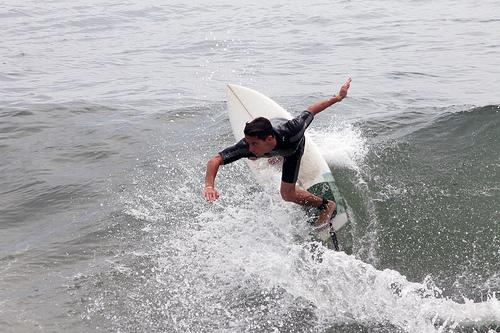Question: what is the man doing?
Choices:
A. Swimming.
B. Skiing.
C. Surfing.
D. Ice skating.
Answer with the letter. Answer: C Question: what motion is the water?
Choices:
A. Still.
B. Smooth.
C. Wavy.
D. Rocky.
Answer with the letter. Answer: C Question: how many people are there?
Choices:
A. Two.
B. One.
C. Three.
D. Four.
Answer with the letter. Answer: B Question: what color is the water?
Choices:
A. Blue.
B. Green.
C. Gray.
D. Brown.
Answer with the letter. Answer: C 